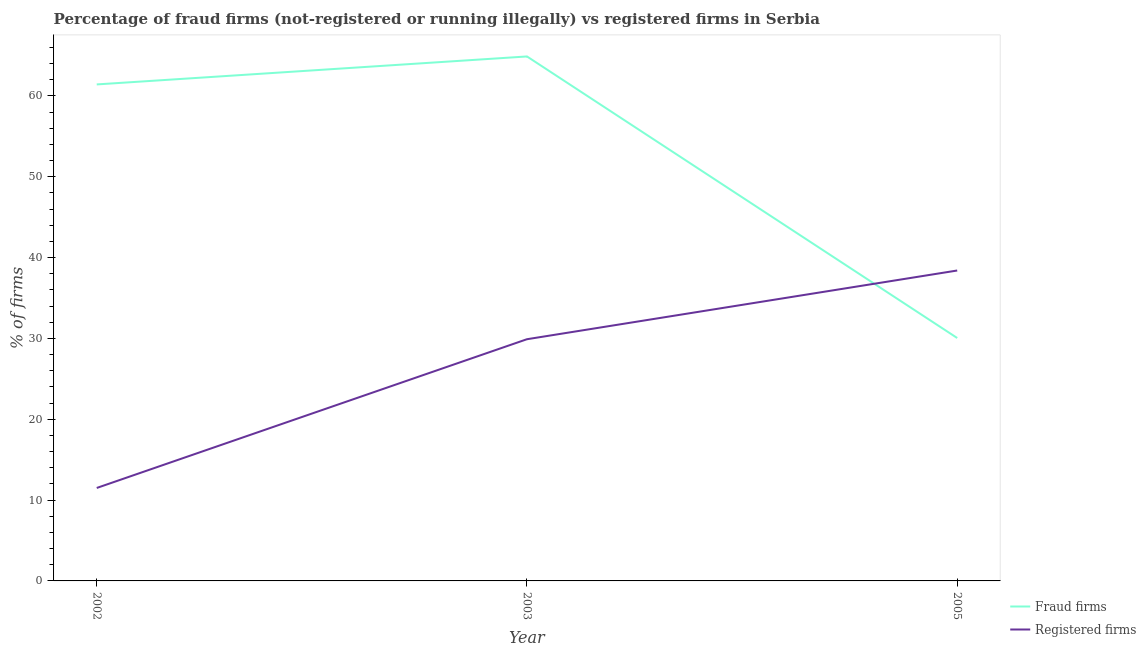Does the line corresponding to percentage of fraud firms intersect with the line corresponding to percentage of registered firms?
Your answer should be very brief. Yes. What is the percentage of registered firms in 2005?
Offer a very short reply. 38.4. Across all years, what is the maximum percentage of fraud firms?
Your answer should be compact. 64.88. Across all years, what is the minimum percentage of fraud firms?
Provide a succinct answer. 30.05. In which year was the percentage of fraud firms minimum?
Give a very brief answer. 2005. What is the total percentage of registered firms in the graph?
Ensure brevity in your answer.  79.8. What is the difference between the percentage of registered firms in 2002 and that in 2005?
Provide a succinct answer. -26.9. What is the difference between the percentage of fraud firms in 2005 and the percentage of registered firms in 2003?
Your response must be concise. 0.15. What is the average percentage of registered firms per year?
Give a very brief answer. 26.6. In the year 2003, what is the difference between the percentage of registered firms and percentage of fraud firms?
Offer a very short reply. -34.98. What is the ratio of the percentage of registered firms in 2003 to that in 2005?
Offer a very short reply. 0.78. What is the difference between the highest and the second highest percentage of fraud firms?
Keep it short and to the point. 3.46. What is the difference between the highest and the lowest percentage of fraud firms?
Keep it short and to the point. 34.83. Is the sum of the percentage of fraud firms in 2002 and 2005 greater than the maximum percentage of registered firms across all years?
Keep it short and to the point. Yes. How many lines are there?
Your response must be concise. 2. How many years are there in the graph?
Provide a succinct answer. 3. Are the values on the major ticks of Y-axis written in scientific E-notation?
Your answer should be compact. No. Does the graph contain any zero values?
Give a very brief answer. No. Does the graph contain grids?
Provide a short and direct response. No. How many legend labels are there?
Your response must be concise. 2. What is the title of the graph?
Offer a very short reply. Percentage of fraud firms (not-registered or running illegally) vs registered firms in Serbia. What is the label or title of the Y-axis?
Offer a terse response. % of firms. What is the % of firms in Fraud firms in 2002?
Make the answer very short. 61.42. What is the % of firms of Fraud firms in 2003?
Make the answer very short. 64.88. What is the % of firms of Registered firms in 2003?
Provide a short and direct response. 29.9. What is the % of firms in Fraud firms in 2005?
Give a very brief answer. 30.05. What is the % of firms of Registered firms in 2005?
Offer a terse response. 38.4. Across all years, what is the maximum % of firms in Fraud firms?
Provide a succinct answer. 64.88. Across all years, what is the maximum % of firms of Registered firms?
Make the answer very short. 38.4. Across all years, what is the minimum % of firms of Fraud firms?
Offer a very short reply. 30.05. What is the total % of firms in Fraud firms in the graph?
Give a very brief answer. 156.35. What is the total % of firms in Registered firms in the graph?
Offer a terse response. 79.8. What is the difference between the % of firms in Fraud firms in 2002 and that in 2003?
Your answer should be very brief. -3.46. What is the difference between the % of firms of Registered firms in 2002 and that in 2003?
Give a very brief answer. -18.4. What is the difference between the % of firms in Fraud firms in 2002 and that in 2005?
Ensure brevity in your answer.  31.37. What is the difference between the % of firms of Registered firms in 2002 and that in 2005?
Your answer should be compact. -26.9. What is the difference between the % of firms of Fraud firms in 2003 and that in 2005?
Your answer should be very brief. 34.83. What is the difference between the % of firms in Registered firms in 2003 and that in 2005?
Your answer should be very brief. -8.5. What is the difference between the % of firms of Fraud firms in 2002 and the % of firms of Registered firms in 2003?
Offer a very short reply. 31.52. What is the difference between the % of firms in Fraud firms in 2002 and the % of firms in Registered firms in 2005?
Make the answer very short. 23.02. What is the difference between the % of firms of Fraud firms in 2003 and the % of firms of Registered firms in 2005?
Provide a succinct answer. 26.48. What is the average % of firms of Fraud firms per year?
Provide a short and direct response. 52.12. What is the average % of firms of Registered firms per year?
Make the answer very short. 26.6. In the year 2002, what is the difference between the % of firms of Fraud firms and % of firms of Registered firms?
Your answer should be compact. 49.92. In the year 2003, what is the difference between the % of firms in Fraud firms and % of firms in Registered firms?
Your answer should be very brief. 34.98. In the year 2005, what is the difference between the % of firms in Fraud firms and % of firms in Registered firms?
Give a very brief answer. -8.35. What is the ratio of the % of firms of Fraud firms in 2002 to that in 2003?
Your response must be concise. 0.95. What is the ratio of the % of firms of Registered firms in 2002 to that in 2003?
Make the answer very short. 0.38. What is the ratio of the % of firms in Fraud firms in 2002 to that in 2005?
Provide a succinct answer. 2.04. What is the ratio of the % of firms in Registered firms in 2002 to that in 2005?
Your response must be concise. 0.3. What is the ratio of the % of firms in Fraud firms in 2003 to that in 2005?
Offer a terse response. 2.16. What is the ratio of the % of firms of Registered firms in 2003 to that in 2005?
Offer a very short reply. 0.78. What is the difference between the highest and the second highest % of firms in Fraud firms?
Ensure brevity in your answer.  3.46. What is the difference between the highest and the lowest % of firms in Fraud firms?
Your response must be concise. 34.83. What is the difference between the highest and the lowest % of firms of Registered firms?
Your answer should be very brief. 26.9. 